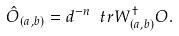<formula> <loc_0><loc_0><loc_500><loc_500>\hat { O } _ { ( a , b ) } = d ^ { - n } \ t r { W _ { ( a , b ) } ^ { \dagger } O } .</formula> 